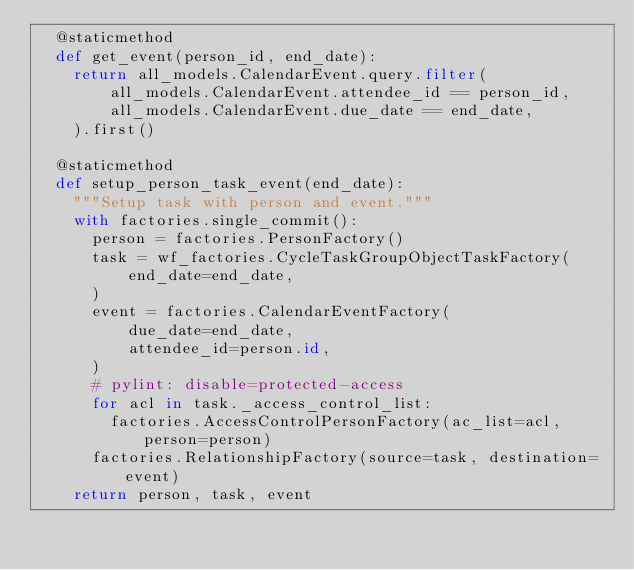<code> <loc_0><loc_0><loc_500><loc_500><_Python_>  @staticmethod
  def get_event(person_id, end_date):
    return all_models.CalendarEvent.query.filter(
        all_models.CalendarEvent.attendee_id == person_id,
        all_models.CalendarEvent.due_date == end_date,
    ).first()

  @staticmethod
  def setup_person_task_event(end_date):
    """Setup task with person and event."""
    with factories.single_commit():
      person = factories.PersonFactory()
      task = wf_factories.CycleTaskGroupObjectTaskFactory(
          end_date=end_date,
      )
      event = factories.CalendarEventFactory(
          due_date=end_date,
          attendee_id=person.id,
      )
      # pylint: disable=protected-access
      for acl in task._access_control_list:
        factories.AccessControlPersonFactory(ac_list=acl, person=person)
      factories.RelationshipFactory(source=task, destination=event)
    return person, task, event
</code> 